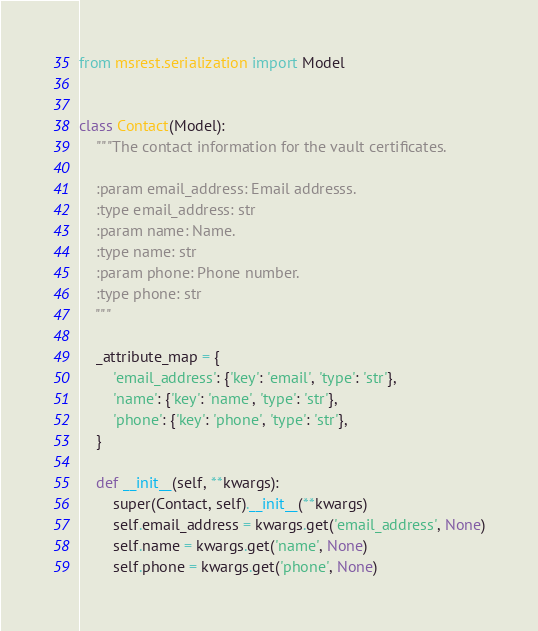<code> <loc_0><loc_0><loc_500><loc_500><_Python_>
from msrest.serialization import Model


class Contact(Model):
    """The contact information for the vault certificates.

    :param email_address: Email addresss.
    :type email_address: str
    :param name: Name.
    :type name: str
    :param phone: Phone number.
    :type phone: str
    """

    _attribute_map = {
        'email_address': {'key': 'email', 'type': 'str'},
        'name': {'key': 'name', 'type': 'str'},
        'phone': {'key': 'phone', 'type': 'str'},
    }

    def __init__(self, **kwargs):
        super(Contact, self).__init__(**kwargs)
        self.email_address = kwargs.get('email_address', None)
        self.name = kwargs.get('name', None)
        self.phone = kwargs.get('phone', None)
</code> 